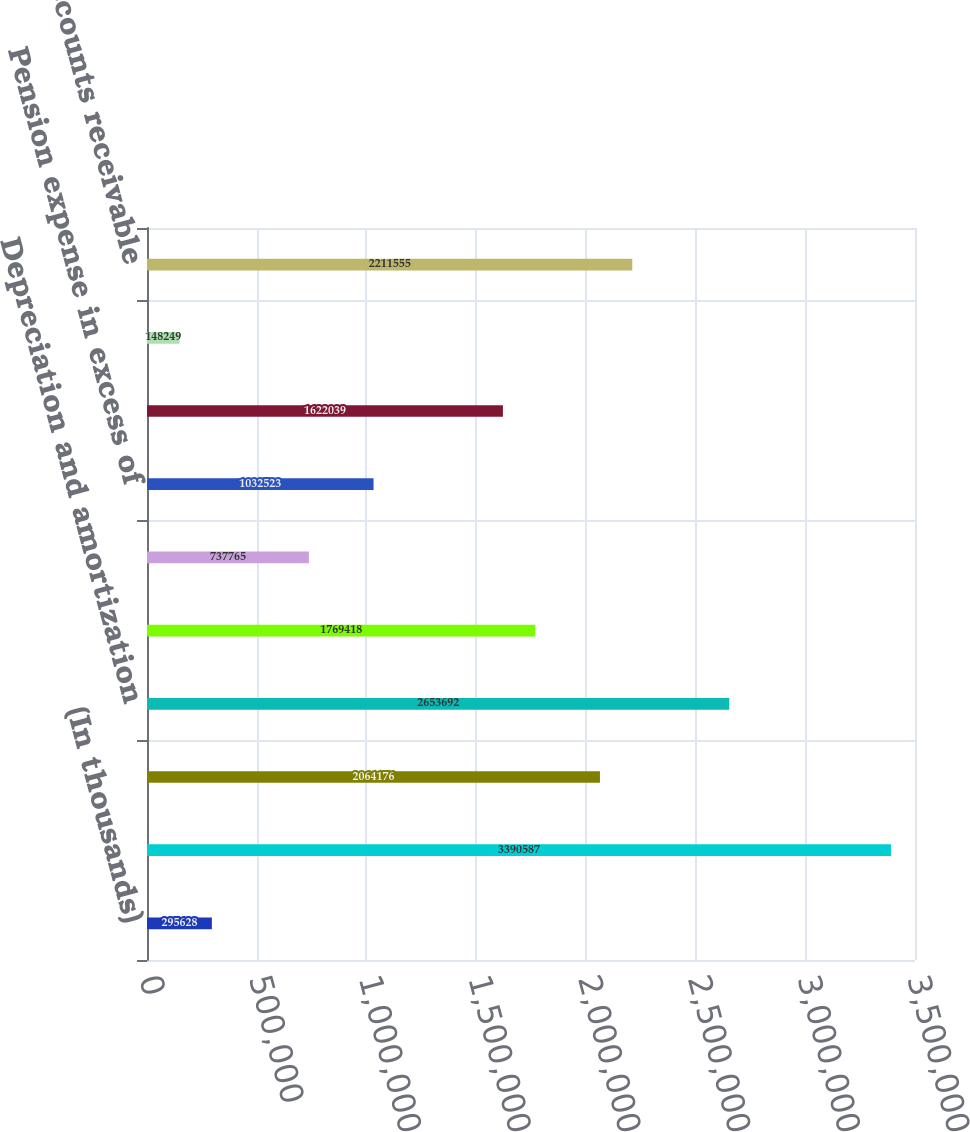<chart> <loc_0><loc_0><loc_500><loc_500><bar_chart><fcel>(In thousands)<fcel>Net income<fcel>Impairment of goodwill and<fcel>Depreciation and amortization<fcel>Stock-based compensation<fcel>Provision for doubtful<fcel>Pension expense in excess of<fcel>Deferred income taxes<fcel>Other net<fcel>Accounts receivable<nl><fcel>295628<fcel>3.39059e+06<fcel>2.06418e+06<fcel>2.65369e+06<fcel>1.76942e+06<fcel>737765<fcel>1.03252e+06<fcel>1.62204e+06<fcel>148249<fcel>2.21156e+06<nl></chart> 